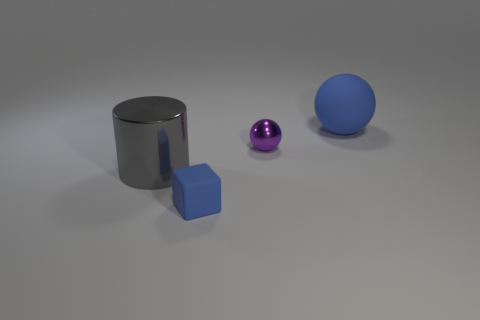There is a object that is the same color as the small block; what shape is it?
Ensure brevity in your answer.  Sphere. Does the small matte cube have the same color as the metal cylinder?
Your answer should be compact. No. Is there a gray rubber thing that has the same shape as the large blue rubber thing?
Your response must be concise. No. What is the color of the other object that is the same size as the gray object?
Give a very brief answer. Blue. There is a metal cylinder left of the big blue rubber sphere; what size is it?
Give a very brief answer. Large. Are there any gray shiny things that are right of the tiny object that is on the right side of the small blue rubber block?
Your answer should be very brief. No. Is the material of the small blue object that is in front of the big matte object the same as the small purple ball?
Offer a terse response. No. What number of blue objects are both on the left side of the purple ball and behind the small shiny object?
Offer a terse response. 0. What number of big gray things are the same material as the tiny blue thing?
Your response must be concise. 0. What color is the other thing that is made of the same material as the large gray thing?
Provide a succinct answer. Purple. 